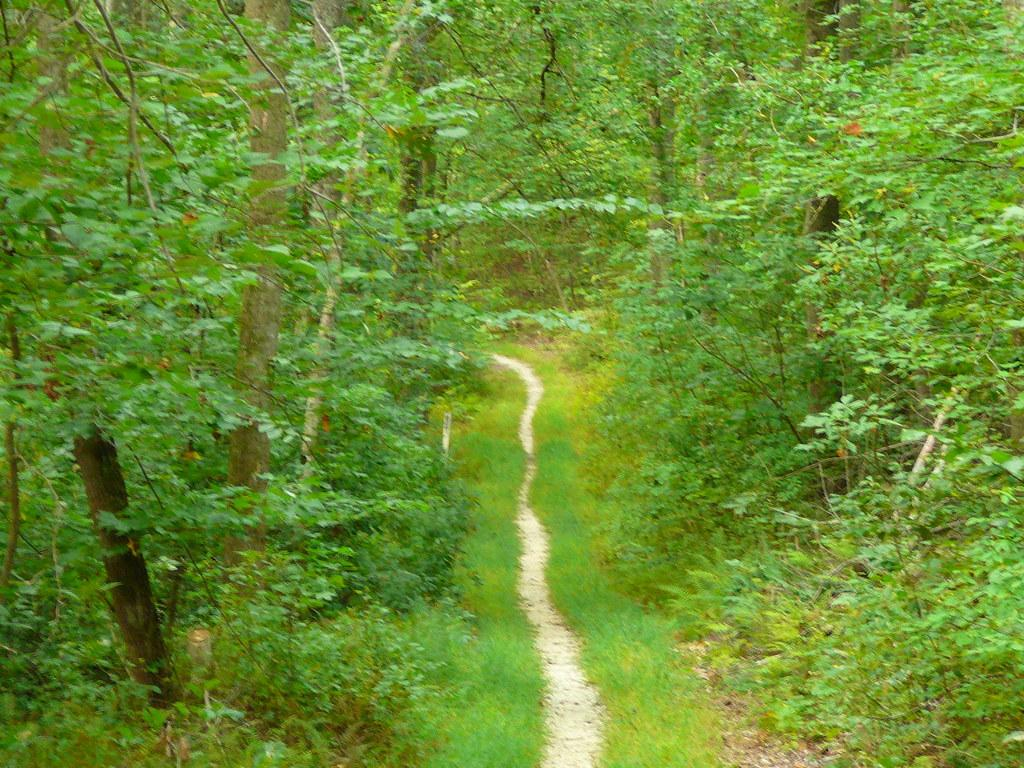What type of environment is depicted in the image? The image appears to depict a forest. What can be seen at the bottom of the image? There is a path at the bottom of the image. What is visible on both sides of the path? Grass is visible on both sides of the path. What is present on the right side of the image? There are many plants and trees on the right side of the image. What is present on the left side of the image? There are many plants and trees on the left side of the image. What type of record can be seen playing in the image? There is no record player or record visible in the image; it depicts a forest with a path and grass. 